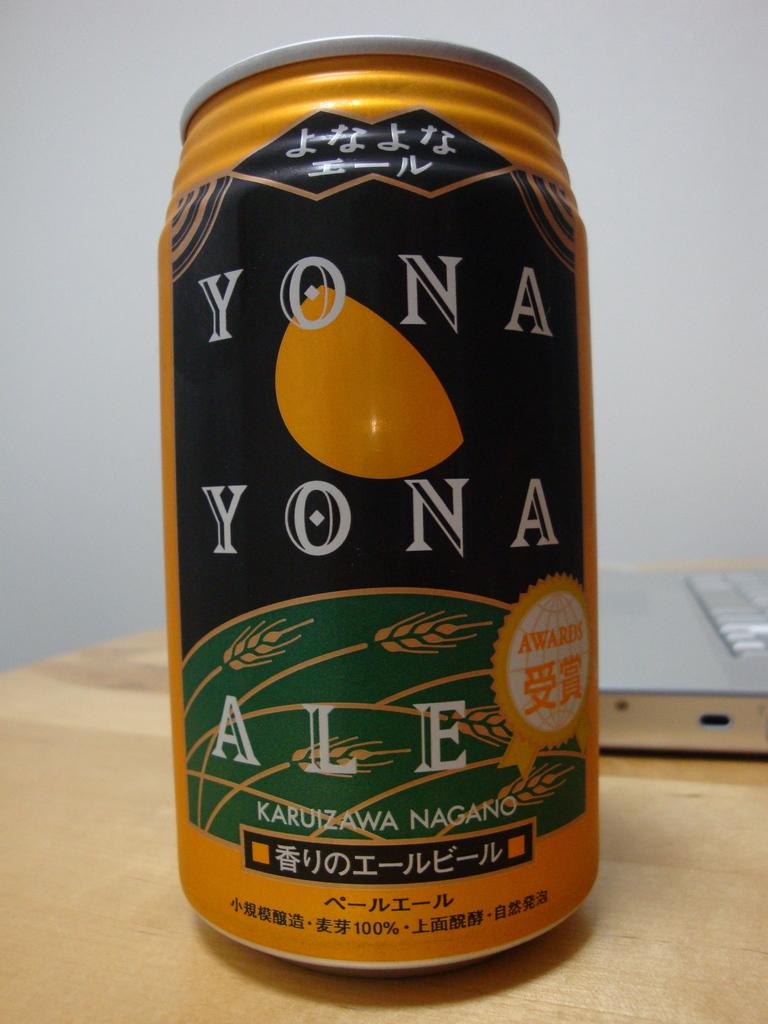<image>
Present a compact description of the photo's key features. A can of Yona Yona Ale sits on a wooden table. 